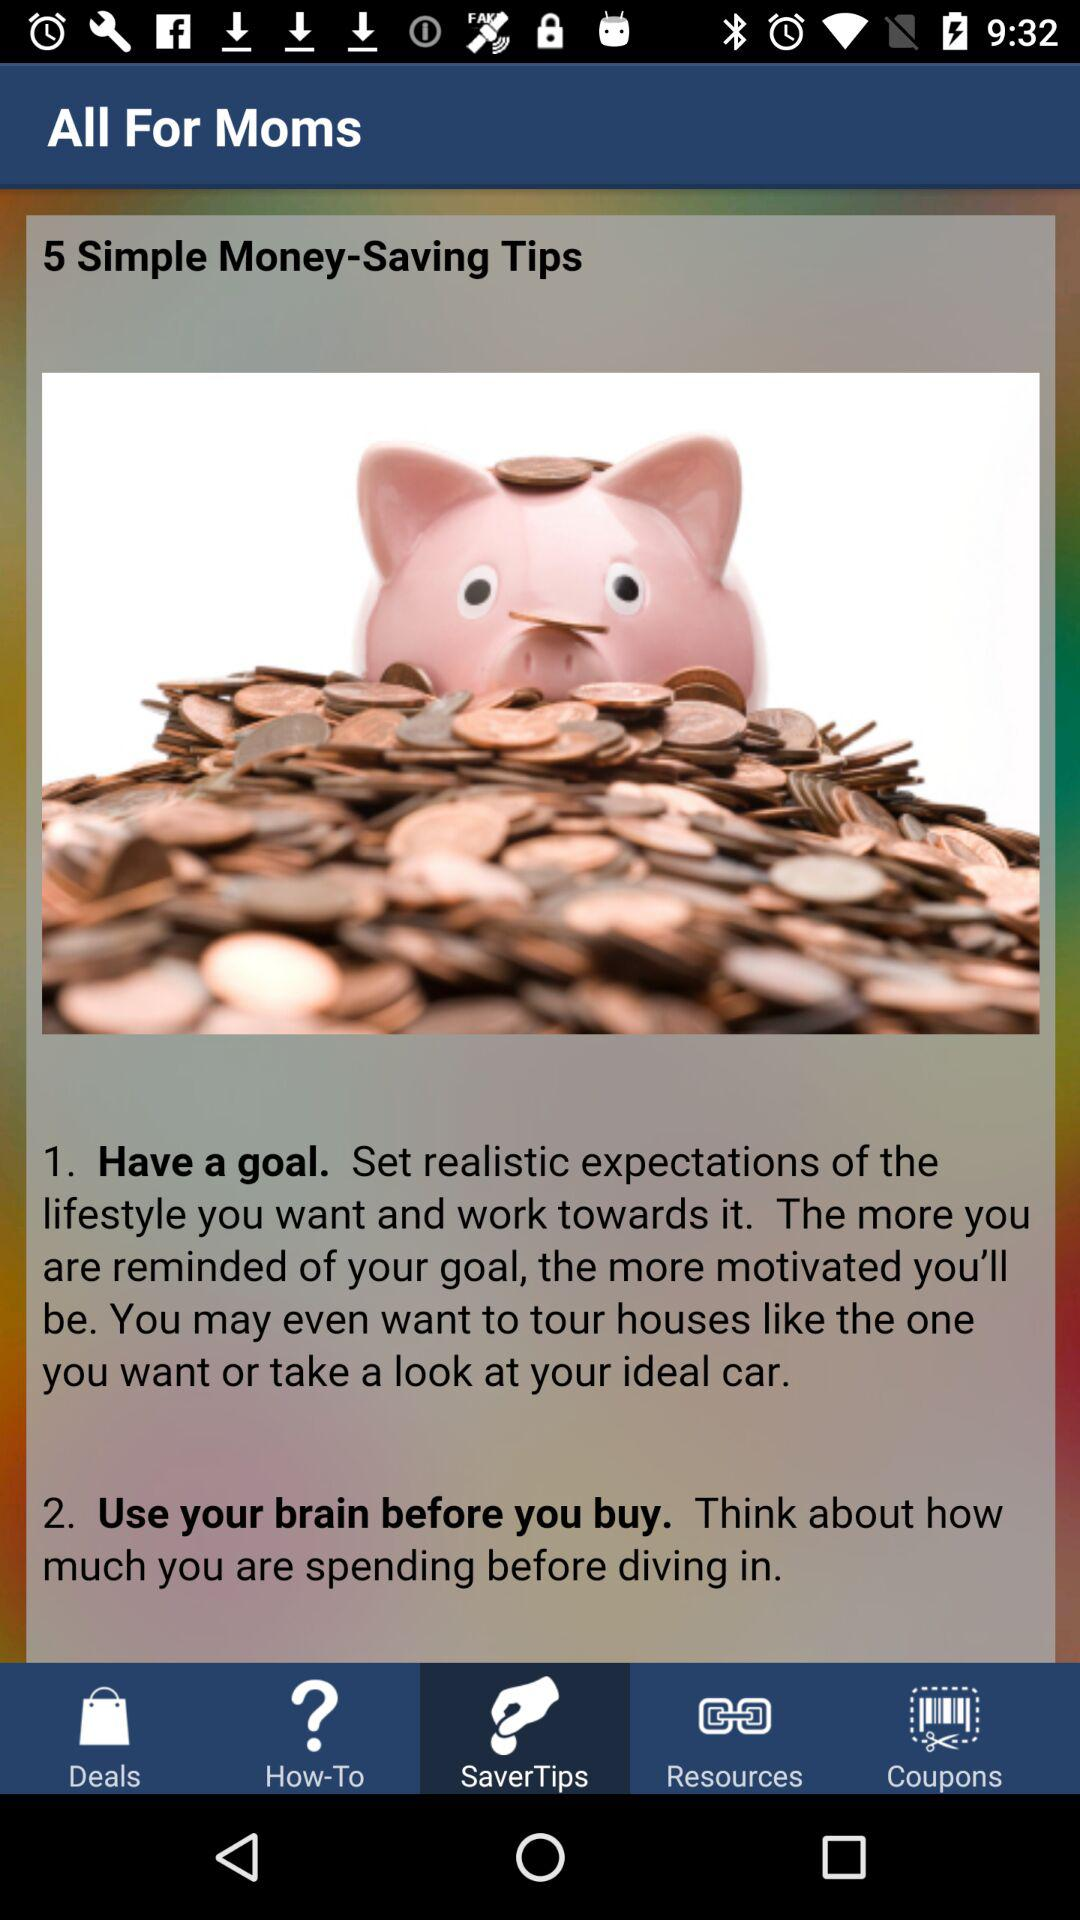What is the first thing that should be done to save money? The first thing that should be done to save money is to "Have a goal". 